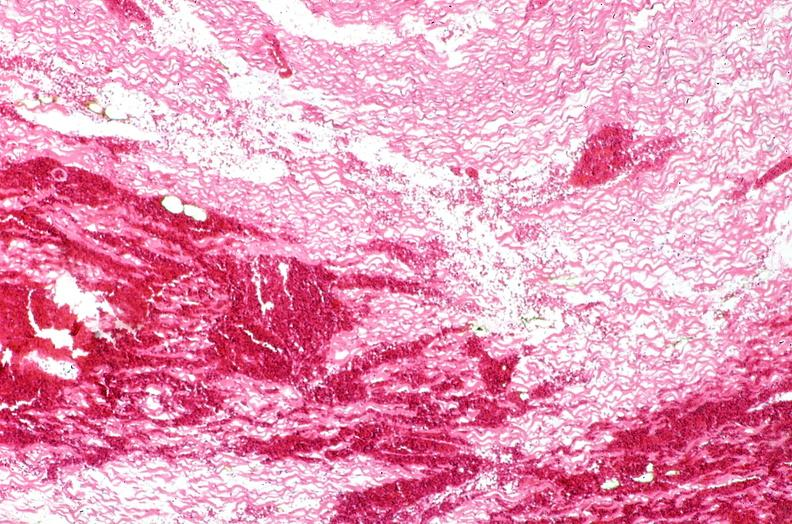where is this from?
Answer the question using a single word or phrase. Heart 